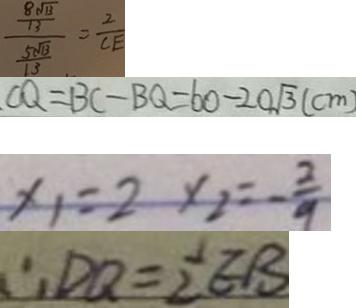<formula> <loc_0><loc_0><loc_500><loc_500>\frac { \frac { 8 \sqrt { 1 3 } } { 1 3 } } { \frac { 5 \sqrt { 1 3 } } { 1 3 } } = \frac { 2 } { C E } 
 C Q = B C - B Q = 6 0 - 2 0 \sqrt { 3 } ( c m ) 
 x _ { 1 } = 2 x _ { 2 } = - \frac { 2 } { 9 } 
 \therefore D Q = \frac { 1 } { 2 } E B</formula> 